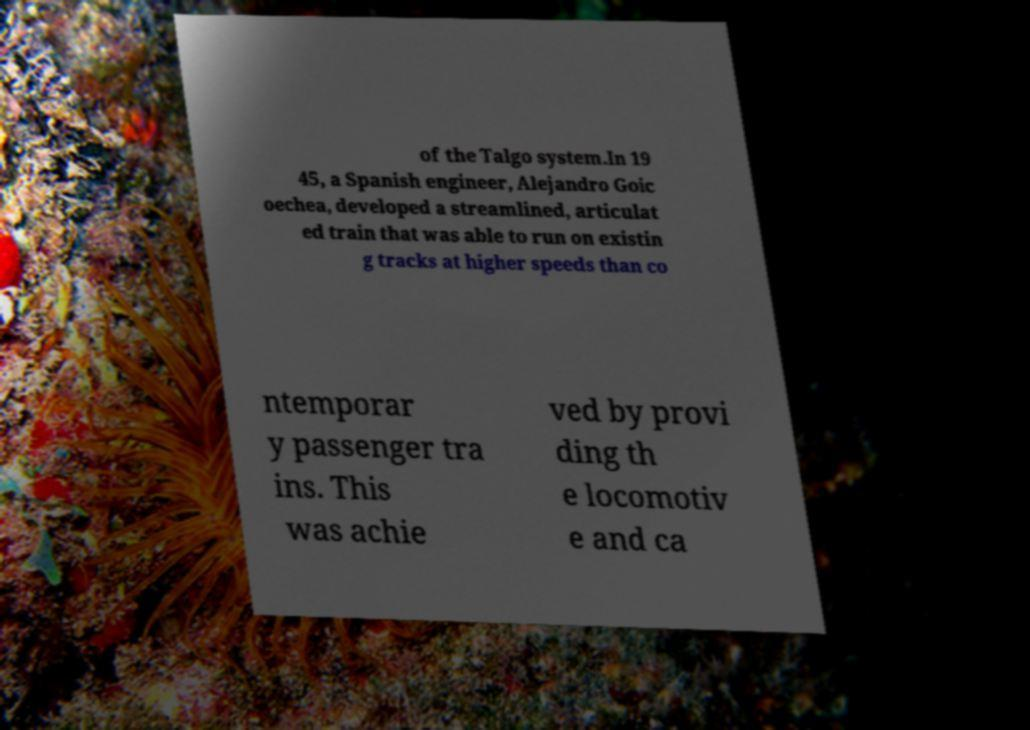Can you read and provide the text displayed in the image?This photo seems to have some interesting text. Can you extract and type it out for me? of the Talgo system.In 19 45, a Spanish engineer, Alejandro Goic oechea, developed a streamlined, articulat ed train that was able to run on existin g tracks at higher speeds than co ntemporar y passenger tra ins. This was achie ved by provi ding th e locomotiv e and ca 